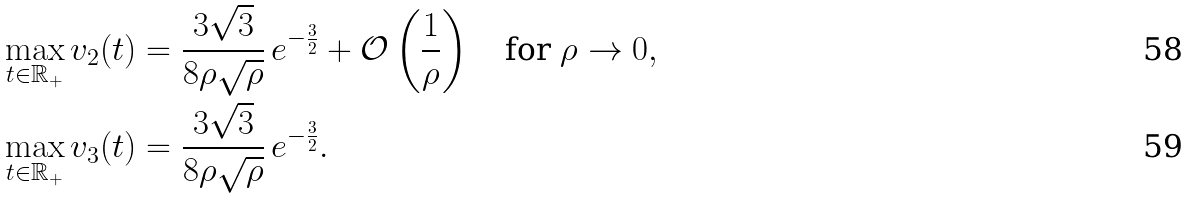Convert formula to latex. <formula><loc_0><loc_0><loc_500><loc_500>\max _ { t \in \mathbb { R } _ { + } } v _ { 2 } ( t ) & = \frac { 3 \sqrt { 3 } } { 8 \rho \sqrt { \rho } } \, e ^ { - \frac { 3 } { 2 } } + \mathcal { O } \left ( \frac { 1 } { \rho } \right ) \quad \text {for } \rho \to 0 , \\ \max _ { t \in \mathbb { R } _ { + } } v _ { 3 } ( t ) & = \frac { 3 \sqrt { 3 } } { 8 \rho \sqrt { \rho } } \, e ^ { - \frac { 3 } { 2 } } .</formula> 